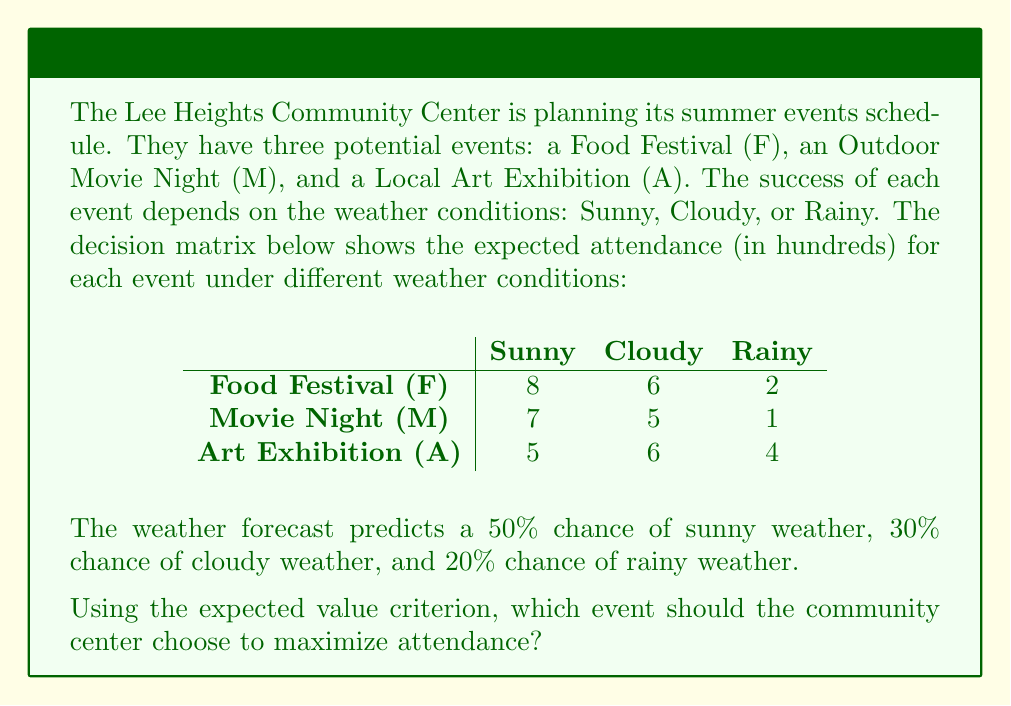Give your solution to this math problem. To solve this problem, we need to calculate the expected value (EV) for each event and choose the one with the highest EV. Here's the step-by-step process:

1. Calculate the probability of each weather condition:
   P(Sunny) = 0.5
   P(Cloudy) = 0.3
   P(Rainy) = 0.2

2. Calculate the EV for each event:

   For Food Festival (F):
   $EV(F) = 8 \times 0.5 + 6 \times 0.3 + 2 \times 0.2$
   $EV(F) = 4 + 1.8 + 0.4 = 6.2$

   For Movie Night (M):
   $EV(M) = 7 \times 0.5 + 5 \times 0.3 + 1 \times 0.2$
   $EV(M) = 3.5 + 1.5 + 0.2 = 5.2$

   For Art Exhibition (A):
   $EV(A) = 5 \times 0.5 + 6 \times 0.3 + 4 \times 0.2$
   $EV(A) = 2.5 + 1.8 + 0.8 = 5.1$

3. Compare the expected values:
   EV(F) = 6.2
   EV(M) = 5.2
   EV(A) = 5.1

The Food Festival (F) has the highest expected value of 6.2, which means it is expected to have the highest attendance given the weather probabilities.
Answer: Food Festival (F) 